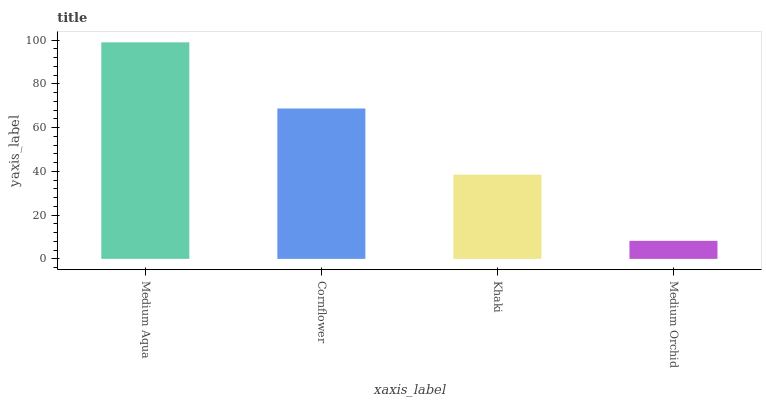Is Medium Orchid the minimum?
Answer yes or no. Yes. Is Medium Aqua the maximum?
Answer yes or no. Yes. Is Cornflower the minimum?
Answer yes or no. No. Is Cornflower the maximum?
Answer yes or no. No. Is Medium Aqua greater than Cornflower?
Answer yes or no. Yes. Is Cornflower less than Medium Aqua?
Answer yes or no. Yes. Is Cornflower greater than Medium Aqua?
Answer yes or no. No. Is Medium Aqua less than Cornflower?
Answer yes or no. No. Is Cornflower the high median?
Answer yes or no. Yes. Is Khaki the low median?
Answer yes or no. Yes. Is Medium Aqua the high median?
Answer yes or no. No. Is Medium Orchid the low median?
Answer yes or no. No. 